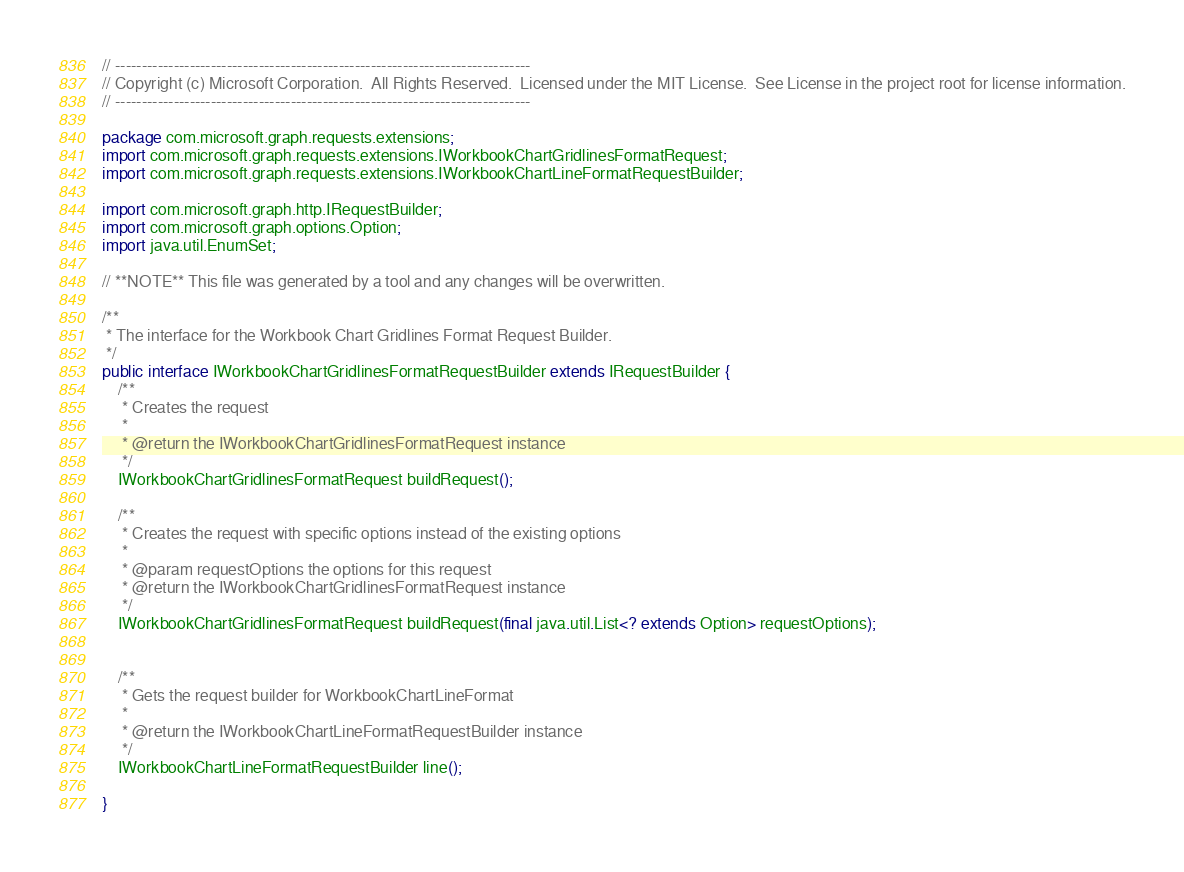<code> <loc_0><loc_0><loc_500><loc_500><_Java_>// ------------------------------------------------------------------------------
// Copyright (c) Microsoft Corporation.  All Rights Reserved.  Licensed under the MIT License.  See License in the project root for license information.
// ------------------------------------------------------------------------------

package com.microsoft.graph.requests.extensions;
import com.microsoft.graph.requests.extensions.IWorkbookChartGridlinesFormatRequest;
import com.microsoft.graph.requests.extensions.IWorkbookChartLineFormatRequestBuilder;

import com.microsoft.graph.http.IRequestBuilder;
import com.microsoft.graph.options.Option;
import java.util.EnumSet;

// **NOTE** This file was generated by a tool and any changes will be overwritten.

/**
 * The interface for the Workbook Chart Gridlines Format Request Builder.
 */
public interface IWorkbookChartGridlinesFormatRequestBuilder extends IRequestBuilder {
    /**
     * Creates the request
     *
     * @return the IWorkbookChartGridlinesFormatRequest instance
     */
    IWorkbookChartGridlinesFormatRequest buildRequest();

    /**
     * Creates the request with specific options instead of the existing options
     *
     * @param requestOptions the options for this request
     * @return the IWorkbookChartGridlinesFormatRequest instance
     */
    IWorkbookChartGridlinesFormatRequest buildRequest(final java.util.List<? extends Option> requestOptions);


    /**
     * Gets the request builder for WorkbookChartLineFormat
     *
     * @return the IWorkbookChartLineFormatRequestBuilder instance
     */
    IWorkbookChartLineFormatRequestBuilder line();

}
</code> 